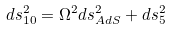Convert formula to latex. <formula><loc_0><loc_0><loc_500><loc_500>d s _ { 1 0 } ^ { 2 } = \Omega ^ { 2 } d s _ { A d S } ^ { 2 } + d s _ { 5 } ^ { 2 }</formula> 